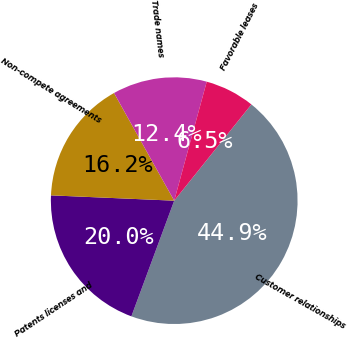Convert chart. <chart><loc_0><loc_0><loc_500><loc_500><pie_chart><fcel>Customer relationships<fcel>Patents licenses and<fcel>Non-compete agreements<fcel>Trade names<fcel>Favorable leases<nl><fcel>44.89%<fcel>20.04%<fcel>16.2%<fcel>12.36%<fcel>6.51%<nl></chart> 